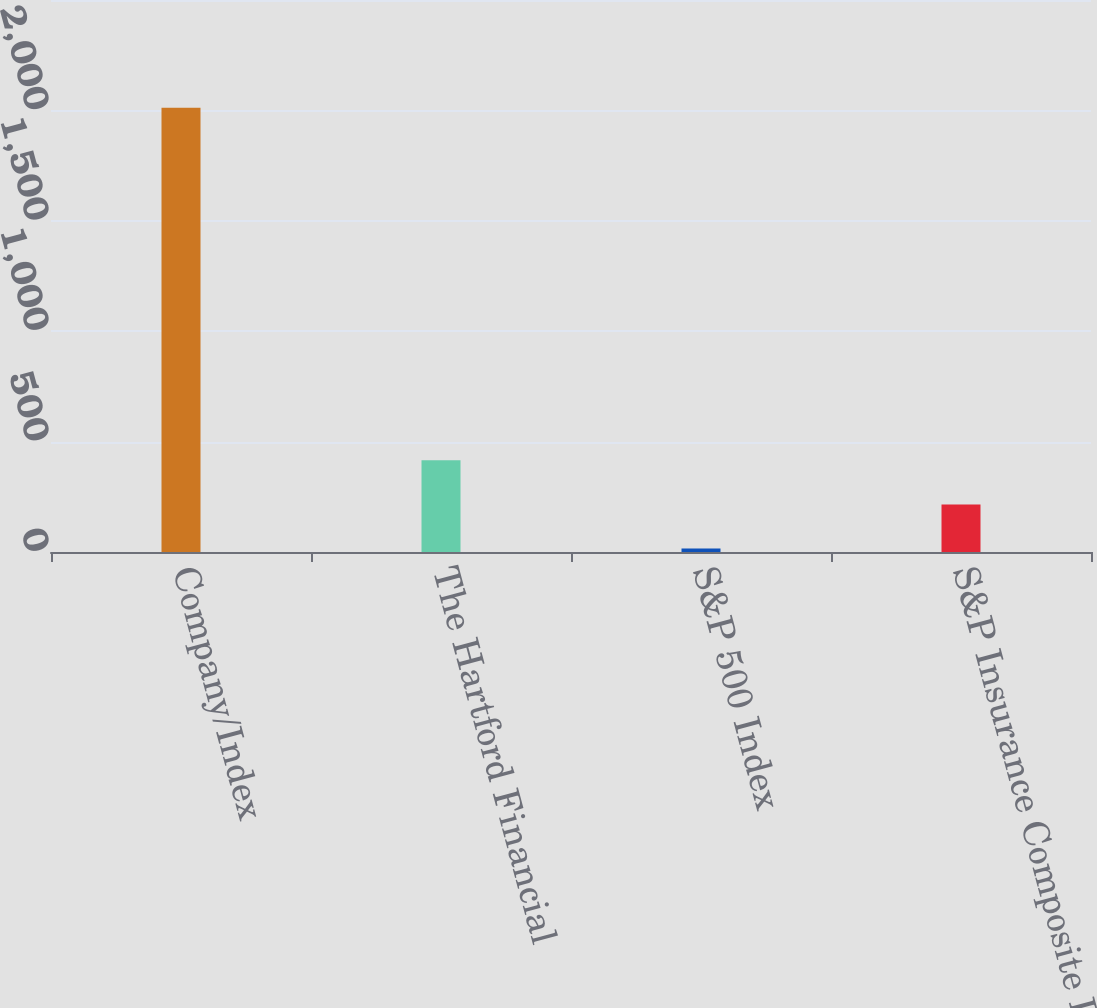Convert chart to OTSL. <chart><loc_0><loc_0><loc_500><loc_500><bar_chart><fcel>Company/Index<fcel>The Hartford Financial<fcel>S&P 500 Index<fcel>S&P Insurance Composite Index<nl><fcel>2012<fcel>415.2<fcel>16<fcel>215.6<nl></chart> 